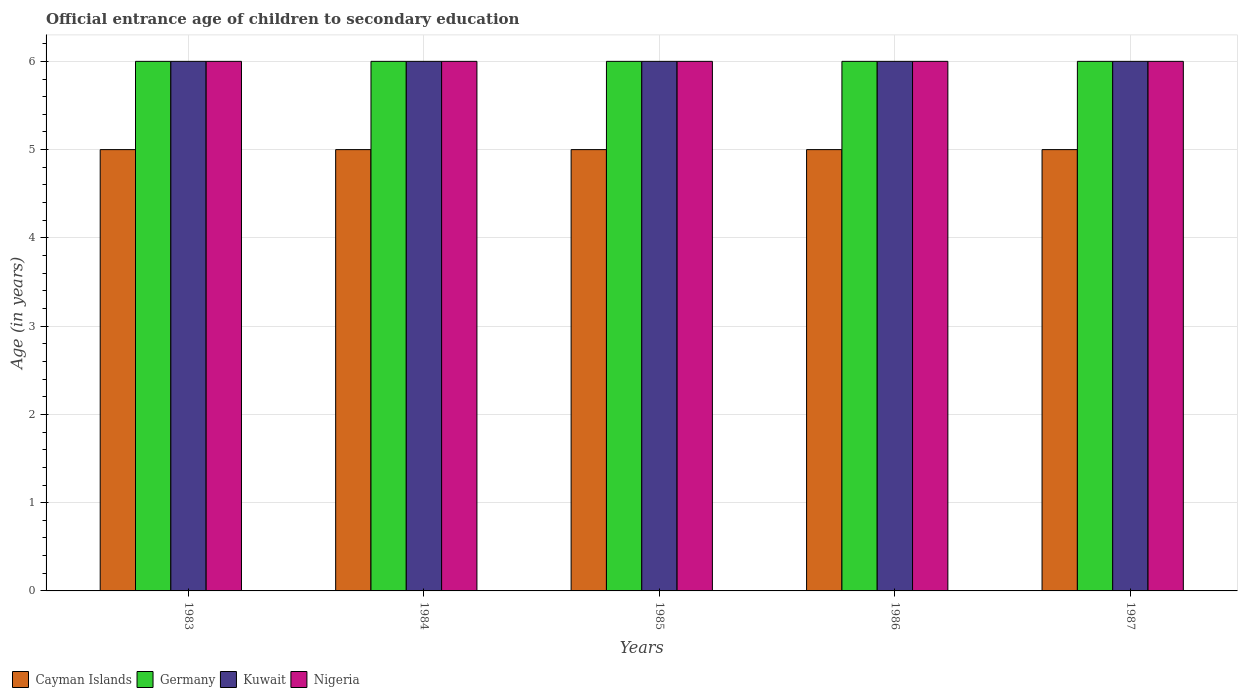Are the number of bars on each tick of the X-axis equal?
Offer a very short reply. Yes. How many bars are there on the 1st tick from the left?
Ensure brevity in your answer.  4. How many bars are there on the 3rd tick from the right?
Your answer should be very brief. 4. What is the label of the 1st group of bars from the left?
Ensure brevity in your answer.  1983. What is the secondary school starting age of children in Cayman Islands in 1985?
Ensure brevity in your answer.  5. What is the total secondary school starting age of children in Nigeria in the graph?
Your answer should be very brief. 30. What is the difference between the secondary school starting age of children in Cayman Islands in 1983 and that in 1987?
Keep it short and to the point. 0. What is the average secondary school starting age of children in Cayman Islands per year?
Your response must be concise. 5. In the year 1986, what is the difference between the secondary school starting age of children in Cayman Islands and secondary school starting age of children in Nigeria?
Keep it short and to the point. -1. What is the difference between the highest and the second highest secondary school starting age of children in Germany?
Make the answer very short. 0. What is the difference between the highest and the lowest secondary school starting age of children in Kuwait?
Give a very brief answer. 0. Is the sum of the secondary school starting age of children in Germany in 1983 and 1984 greater than the maximum secondary school starting age of children in Cayman Islands across all years?
Your answer should be compact. Yes. What does the 1st bar from the left in 1987 represents?
Your answer should be compact. Cayman Islands. What does the 2nd bar from the right in 1984 represents?
Your answer should be very brief. Kuwait. Is it the case that in every year, the sum of the secondary school starting age of children in Germany and secondary school starting age of children in Kuwait is greater than the secondary school starting age of children in Cayman Islands?
Make the answer very short. Yes. Are all the bars in the graph horizontal?
Your answer should be compact. No. How many years are there in the graph?
Your answer should be very brief. 5. Are the values on the major ticks of Y-axis written in scientific E-notation?
Offer a very short reply. No. Does the graph contain any zero values?
Give a very brief answer. No. Does the graph contain grids?
Offer a terse response. Yes. Where does the legend appear in the graph?
Ensure brevity in your answer.  Bottom left. How many legend labels are there?
Keep it short and to the point. 4. What is the title of the graph?
Keep it short and to the point. Official entrance age of children to secondary education. Does "Sudan" appear as one of the legend labels in the graph?
Keep it short and to the point. No. What is the label or title of the X-axis?
Give a very brief answer. Years. What is the label or title of the Y-axis?
Your answer should be compact. Age (in years). What is the Age (in years) of Cayman Islands in 1983?
Your answer should be compact. 5. What is the Age (in years) in Nigeria in 1983?
Your response must be concise. 6. What is the Age (in years) of Germany in 1984?
Keep it short and to the point. 6. What is the Age (in years) of Kuwait in 1984?
Your answer should be very brief. 6. What is the Age (in years) of Cayman Islands in 1985?
Your answer should be compact. 5. What is the Age (in years) of Germany in 1985?
Offer a very short reply. 6. What is the Age (in years) of Kuwait in 1985?
Your answer should be compact. 6. What is the Age (in years) of Nigeria in 1985?
Give a very brief answer. 6. What is the Age (in years) of Germany in 1986?
Provide a succinct answer. 6. What is the Age (in years) of Nigeria in 1986?
Ensure brevity in your answer.  6. What is the Age (in years) of Germany in 1987?
Keep it short and to the point. 6. What is the Age (in years) of Nigeria in 1987?
Provide a succinct answer. 6. Across all years, what is the maximum Age (in years) in Germany?
Keep it short and to the point. 6. Across all years, what is the maximum Age (in years) of Nigeria?
Offer a terse response. 6. Across all years, what is the minimum Age (in years) of Cayman Islands?
Keep it short and to the point. 5. Across all years, what is the minimum Age (in years) of Kuwait?
Ensure brevity in your answer.  6. What is the difference between the Age (in years) in Cayman Islands in 1983 and that in 1984?
Make the answer very short. 0. What is the difference between the Age (in years) of Germany in 1983 and that in 1984?
Offer a terse response. 0. What is the difference between the Age (in years) of Germany in 1983 and that in 1986?
Give a very brief answer. 0. What is the difference between the Age (in years) in Kuwait in 1983 and that in 1986?
Provide a succinct answer. 0. What is the difference between the Age (in years) in Nigeria in 1983 and that in 1986?
Give a very brief answer. 0. What is the difference between the Age (in years) of Kuwait in 1983 and that in 1987?
Offer a terse response. 0. What is the difference between the Age (in years) of Nigeria in 1983 and that in 1987?
Ensure brevity in your answer.  0. What is the difference between the Age (in years) of Cayman Islands in 1984 and that in 1985?
Give a very brief answer. 0. What is the difference between the Age (in years) of Kuwait in 1984 and that in 1985?
Your response must be concise. 0. What is the difference between the Age (in years) in Nigeria in 1984 and that in 1985?
Your response must be concise. 0. What is the difference between the Age (in years) of Germany in 1984 and that in 1987?
Your response must be concise. 0. What is the difference between the Age (in years) of Kuwait in 1984 and that in 1987?
Make the answer very short. 0. What is the difference between the Age (in years) of Nigeria in 1984 and that in 1987?
Your response must be concise. 0. What is the difference between the Age (in years) of Cayman Islands in 1985 and that in 1986?
Offer a terse response. 0. What is the difference between the Age (in years) in Germany in 1985 and that in 1986?
Make the answer very short. 0. What is the difference between the Age (in years) in Nigeria in 1985 and that in 1986?
Provide a succinct answer. 0. What is the difference between the Age (in years) of Kuwait in 1986 and that in 1987?
Your response must be concise. 0. What is the difference between the Age (in years) of Cayman Islands in 1983 and the Age (in years) of Germany in 1984?
Provide a succinct answer. -1. What is the difference between the Age (in years) in Germany in 1983 and the Age (in years) in Nigeria in 1984?
Your answer should be compact. 0. What is the difference between the Age (in years) in Cayman Islands in 1983 and the Age (in years) in Germany in 1985?
Ensure brevity in your answer.  -1. What is the difference between the Age (in years) in Germany in 1983 and the Age (in years) in Kuwait in 1985?
Ensure brevity in your answer.  0. What is the difference between the Age (in years) of Kuwait in 1983 and the Age (in years) of Nigeria in 1985?
Ensure brevity in your answer.  0. What is the difference between the Age (in years) of Cayman Islands in 1983 and the Age (in years) of Germany in 1986?
Offer a terse response. -1. What is the difference between the Age (in years) in Germany in 1983 and the Age (in years) in Kuwait in 1986?
Provide a short and direct response. 0. What is the difference between the Age (in years) of Kuwait in 1983 and the Age (in years) of Nigeria in 1986?
Give a very brief answer. 0. What is the difference between the Age (in years) in Germany in 1983 and the Age (in years) in Nigeria in 1987?
Offer a very short reply. 0. What is the difference between the Age (in years) in Kuwait in 1984 and the Age (in years) in Nigeria in 1985?
Provide a succinct answer. 0. What is the difference between the Age (in years) in Kuwait in 1984 and the Age (in years) in Nigeria in 1986?
Offer a very short reply. 0. What is the difference between the Age (in years) in Cayman Islands in 1984 and the Age (in years) in Kuwait in 1987?
Offer a very short reply. -1. What is the difference between the Age (in years) of Cayman Islands in 1984 and the Age (in years) of Nigeria in 1987?
Your response must be concise. -1. What is the difference between the Age (in years) of Cayman Islands in 1985 and the Age (in years) of Kuwait in 1986?
Provide a short and direct response. -1. What is the difference between the Age (in years) in Germany in 1985 and the Age (in years) in Kuwait in 1986?
Provide a succinct answer. 0. What is the difference between the Age (in years) in Germany in 1985 and the Age (in years) in Nigeria in 1986?
Keep it short and to the point. 0. What is the difference between the Age (in years) of Cayman Islands in 1985 and the Age (in years) of Germany in 1987?
Offer a terse response. -1. What is the difference between the Age (in years) in Cayman Islands in 1985 and the Age (in years) in Kuwait in 1987?
Your answer should be compact. -1. What is the difference between the Age (in years) of Cayman Islands in 1985 and the Age (in years) of Nigeria in 1987?
Your answer should be compact. -1. What is the difference between the Age (in years) of Kuwait in 1985 and the Age (in years) of Nigeria in 1987?
Keep it short and to the point. 0. What is the difference between the Age (in years) in Cayman Islands in 1986 and the Age (in years) in Nigeria in 1987?
Offer a terse response. -1. What is the difference between the Age (in years) in Germany in 1986 and the Age (in years) in Nigeria in 1987?
Ensure brevity in your answer.  0. What is the average Age (in years) of Cayman Islands per year?
Your answer should be compact. 5. What is the average Age (in years) of Germany per year?
Provide a short and direct response. 6. What is the average Age (in years) in Kuwait per year?
Provide a short and direct response. 6. What is the average Age (in years) in Nigeria per year?
Offer a very short reply. 6. In the year 1983, what is the difference between the Age (in years) in Cayman Islands and Age (in years) in Kuwait?
Your answer should be compact. -1. In the year 1983, what is the difference between the Age (in years) in Cayman Islands and Age (in years) in Nigeria?
Provide a short and direct response. -1. In the year 1984, what is the difference between the Age (in years) in Cayman Islands and Age (in years) in Germany?
Offer a very short reply. -1. In the year 1984, what is the difference between the Age (in years) in Cayman Islands and Age (in years) in Kuwait?
Your answer should be very brief. -1. In the year 1984, what is the difference between the Age (in years) of Cayman Islands and Age (in years) of Nigeria?
Keep it short and to the point. -1. In the year 1984, what is the difference between the Age (in years) in Germany and Age (in years) in Nigeria?
Provide a succinct answer. 0. In the year 1984, what is the difference between the Age (in years) of Kuwait and Age (in years) of Nigeria?
Keep it short and to the point. 0. In the year 1985, what is the difference between the Age (in years) of Cayman Islands and Age (in years) of Germany?
Provide a succinct answer. -1. In the year 1985, what is the difference between the Age (in years) of Germany and Age (in years) of Kuwait?
Offer a terse response. 0. In the year 1985, what is the difference between the Age (in years) in Germany and Age (in years) in Nigeria?
Provide a succinct answer. 0. In the year 1986, what is the difference between the Age (in years) of Cayman Islands and Age (in years) of Germany?
Your response must be concise. -1. In the year 1986, what is the difference between the Age (in years) in Germany and Age (in years) in Nigeria?
Make the answer very short. 0. In the year 1987, what is the difference between the Age (in years) of Germany and Age (in years) of Nigeria?
Give a very brief answer. 0. What is the ratio of the Age (in years) in Cayman Islands in 1983 to that in 1984?
Offer a terse response. 1. What is the ratio of the Age (in years) of Cayman Islands in 1983 to that in 1985?
Offer a terse response. 1. What is the ratio of the Age (in years) in Kuwait in 1983 to that in 1985?
Keep it short and to the point. 1. What is the ratio of the Age (in years) of Germany in 1983 to that in 1986?
Your answer should be very brief. 1. What is the ratio of the Age (in years) in Kuwait in 1983 to that in 1986?
Provide a short and direct response. 1. What is the ratio of the Age (in years) of Germany in 1983 to that in 1987?
Ensure brevity in your answer.  1. What is the ratio of the Age (in years) of Kuwait in 1983 to that in 1987?
Keep it short and to the point. 1. What is the ratio of the Age (in years) in Nigeria in 1983 to that in 1987?
Your answer should be very brief. 1. What is the ratio of the Age (in years) of Cayman Islands in 1984 to that in 1985?
Your answer should be very brief. 1. What is the ratio of the Age (in years) in Germany in 1984 to that in 1985?
Keep it short and to the point. 1. What is the ratio of the Age (in years) in Germany in 1984 to that in 1986?
Ensure brevity in your answer.  1. What is the ratio of the Age (in years) of Germany in 1984 to that in 1987?
Offer a very short reply. 1. What is the ratio of the Age (in years) in Kuwait in 1984 to that in 1987?
Ensure brevity in your answer.  1. What is the ratio of the Age (in years) of Cayman Islands in 1985 to that in 1986?
Keep it short and to the point. 1. What is the ratio of the Age (in years) of Kuwait in 1985 to that in 1986?
Your answer should be compact. 1. What is the ratio of the Age (in years) in Cayman Islands in 1985 to that in 1987?
Your response must be concise. 1. What is the ratio of the Age (in years) of Germany in 1985 to that in 1987?
Make the answer very short. 1. What is the ratio of the Age (in years) in Kuwait in 1985 to that in 1987?
Your answer should be compact. 1. What is the ratio of the Age (in years) in Germany in 1986 to that in 1987?
Your answer should be very brief. 1. What is the ratio of the Age (in years) in Kuwait in 1986 to that in 1987?
Make the answer very short. 1. What is the ratio of the Age (in years) of Nigeria in 1986 to that in 1987?
Your response must be concise. 1. What is the difference between the highest and the second highest Age (in years) in Cayman Islands?
Your response must be concise. 0. What is the difference between the highest and the second highest Age (in years) in Kuwait?
Your answer should be very brief. 0. What is the difference between the highest and the lowest Age (in years) of Germany?
Provide a succinct answer. 0. What is the difference between the highest and the lowest Age (in years) in Kuwait?
Keep it short and to the point. 0. 